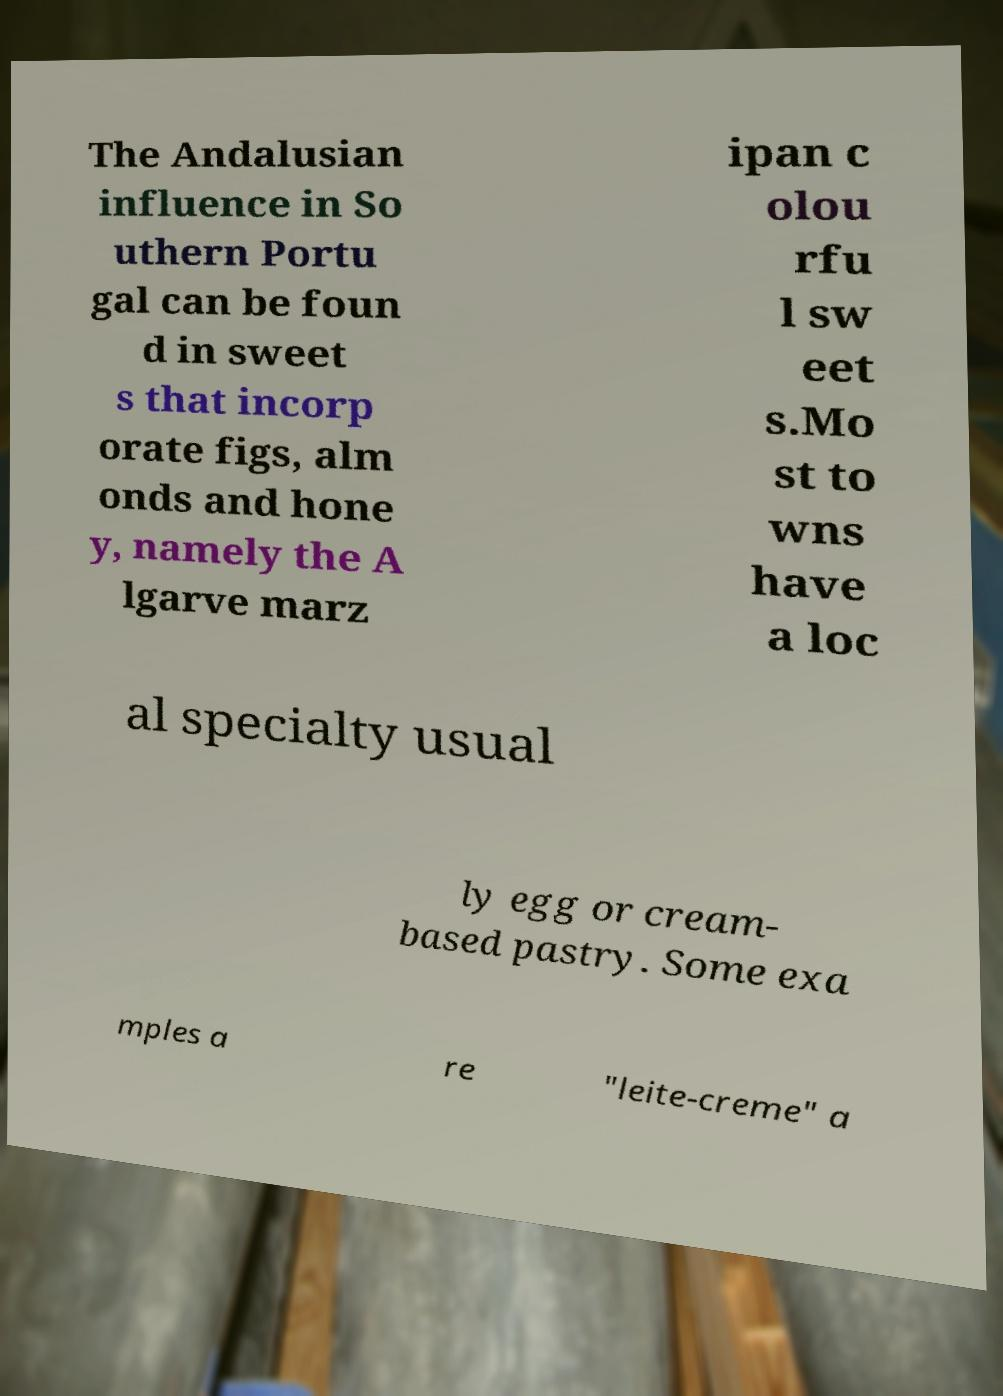For documentation purposes, I need the text within this image transcribed. Could you provide that? The Andalusian influence in So uthern Portu gal can be foun d in sweet s that incorp orate figs, alm onds and hone y, namely the A lgarve marz ipan c olou rfu l sw eet s.Mo st to wns have a loc al specialty usual ly egg or cream- based pastry. Some exa mples a re "leite-creme" a 